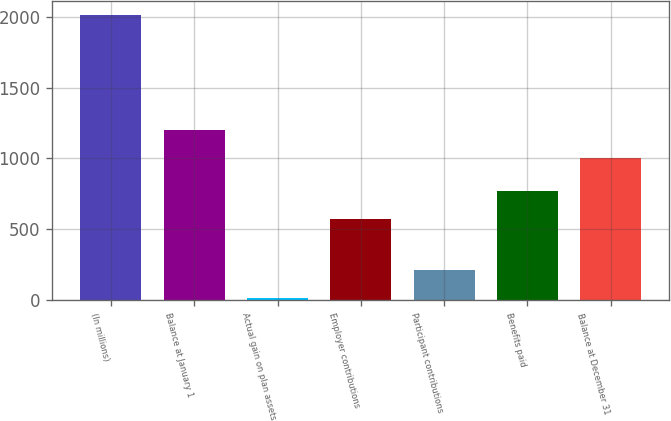<chart> <loc_0><loc_0><loc_500><loc_500><bar_chart><fcel>(In millions)<fcel>Balance at January 1<fcel>Actual gain on plan assets<fcel>Employer contributions<fcel>Participant contributions<fcel>Benefits paid<fcel>Balance at December 31<nl><fcel>2011<fcel>1203.6<fcel>15<fcel>574<fcel>214.6<fcel>773.6<fcel>1004<nl></chart> 